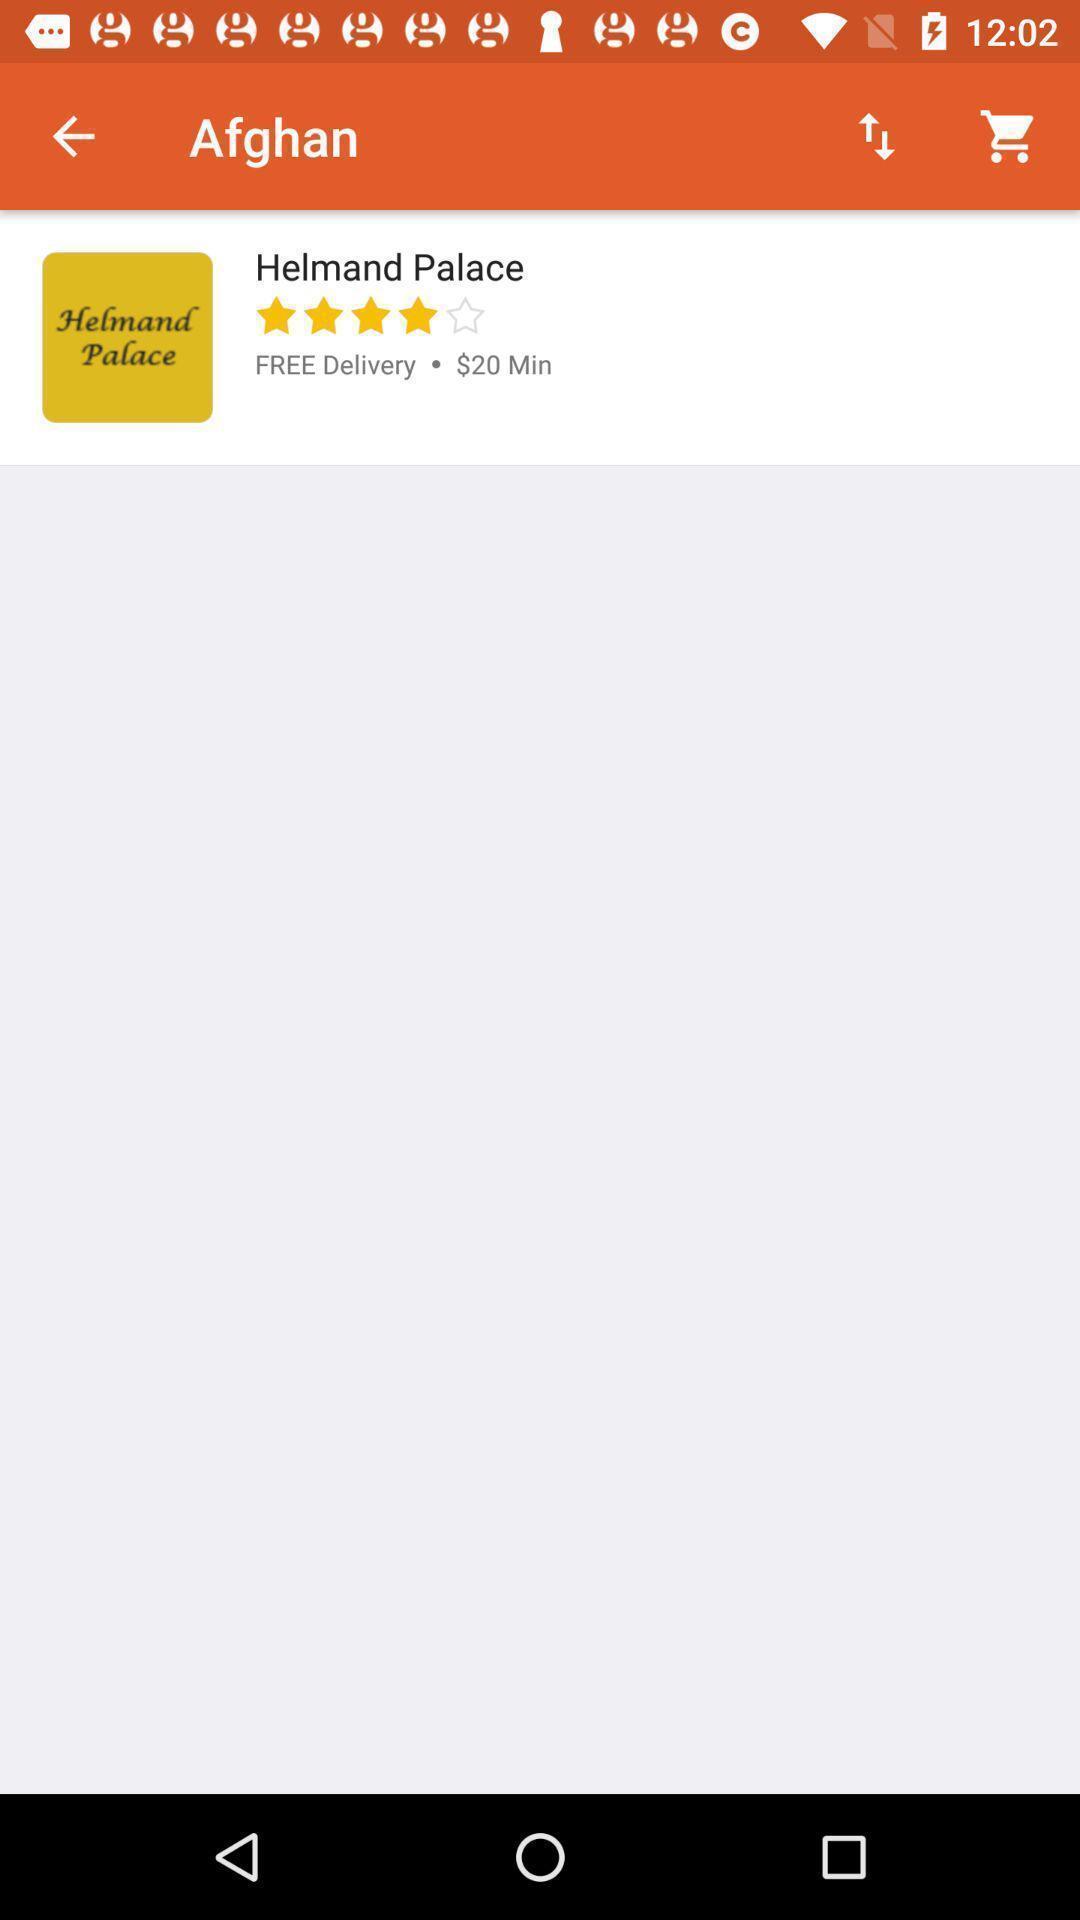What details can you identify in this image? Screen displaying a place information with price details. 